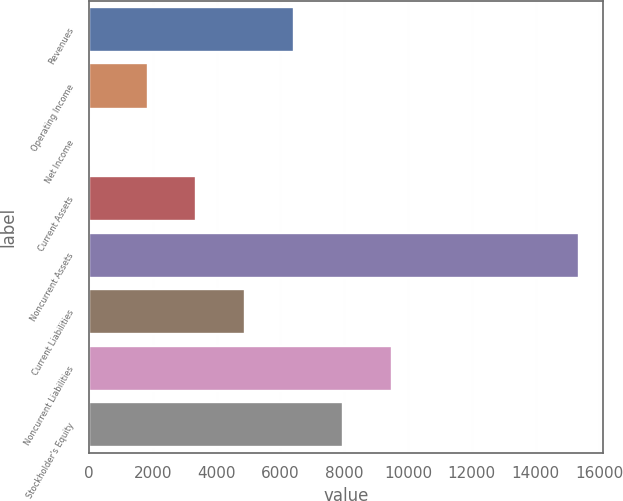<chart> <loc_0><loc_0><loc_500><loc_500><bar_chart><fcel>Revenues<fcel>Operating Income<fcel>Net Income<fcel>Current Assets<fcel>Noncurrent Assets<fcel>Current Liabilities<fcel>Noncurrent Liabilities<fcel>Stockholder's Equity<nl><fcel>6428.1<fcel>1839<fcel>62<fcel>3368.7<fcel>15359<fcel>4898.4<fcel>9487.5<fcel>7957.8<nl></chart> 